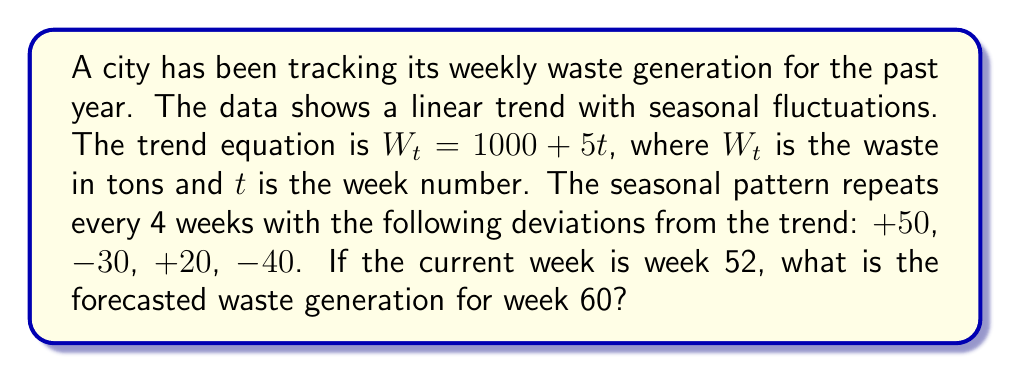Can you solve this math problem? To solve this problem, we'll follow these steps:

1. Calculate the trend component for week 60:
   $$W_{60} = 1000 + 5(60) = 1300\text{ tons}$$

2. Determine the seasonal component for week 60:
   - Week 60 is equivalent to week 4 in the seasonal cycle (60 ÷ 4 = 15 remainder 0)
   - The seasonal deviation for week 4 is -40 tons

3. Combine the trend and seasonal components:
   $$\text{Forecast} = \text{Trend} + \text{Seasonal}$$
   $$\text{Forecast} = 1300 + (-40) = 1260\text{ tons}$$

Therefore, the forecasted waste generation for week 60 is 1260 tons.
Answer: 1260 tons 